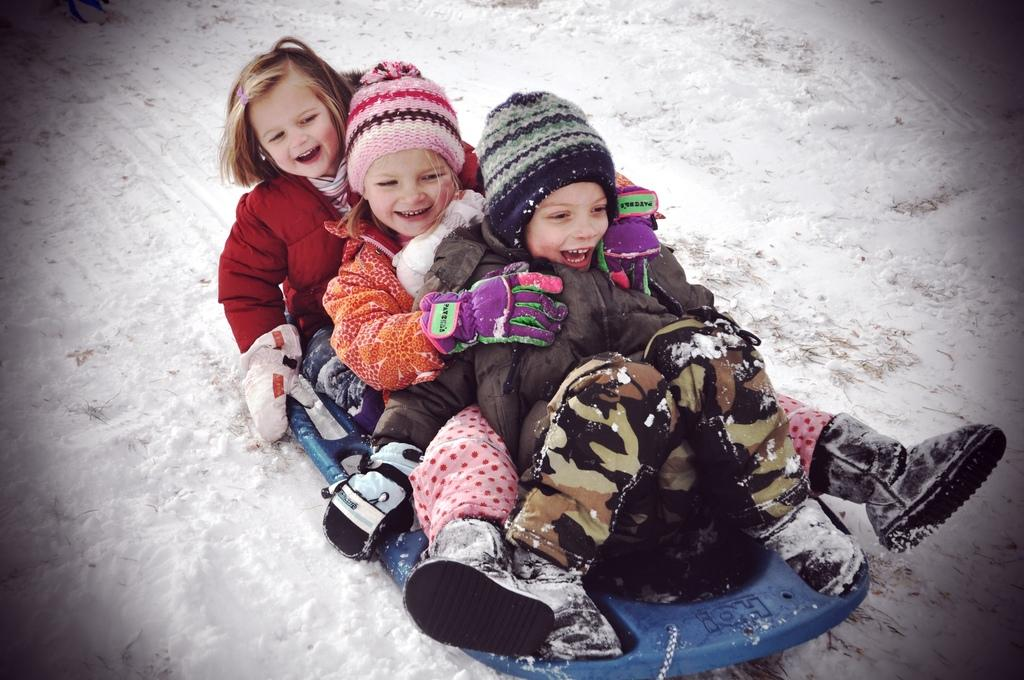How many kids are present in the image? There are 3 kids in the image. What are the kids doing in the image? The kids are playing in the snow. What clothing items are the kids wearing to protect them from the cold? The kids are wearing coats and caps. What is the main element in the background of the image? The snow is visible in the image. What type of cat can be seen playing with the kids in the image? There is no cat present in the image; the kids are playing in the snow without any animals. 